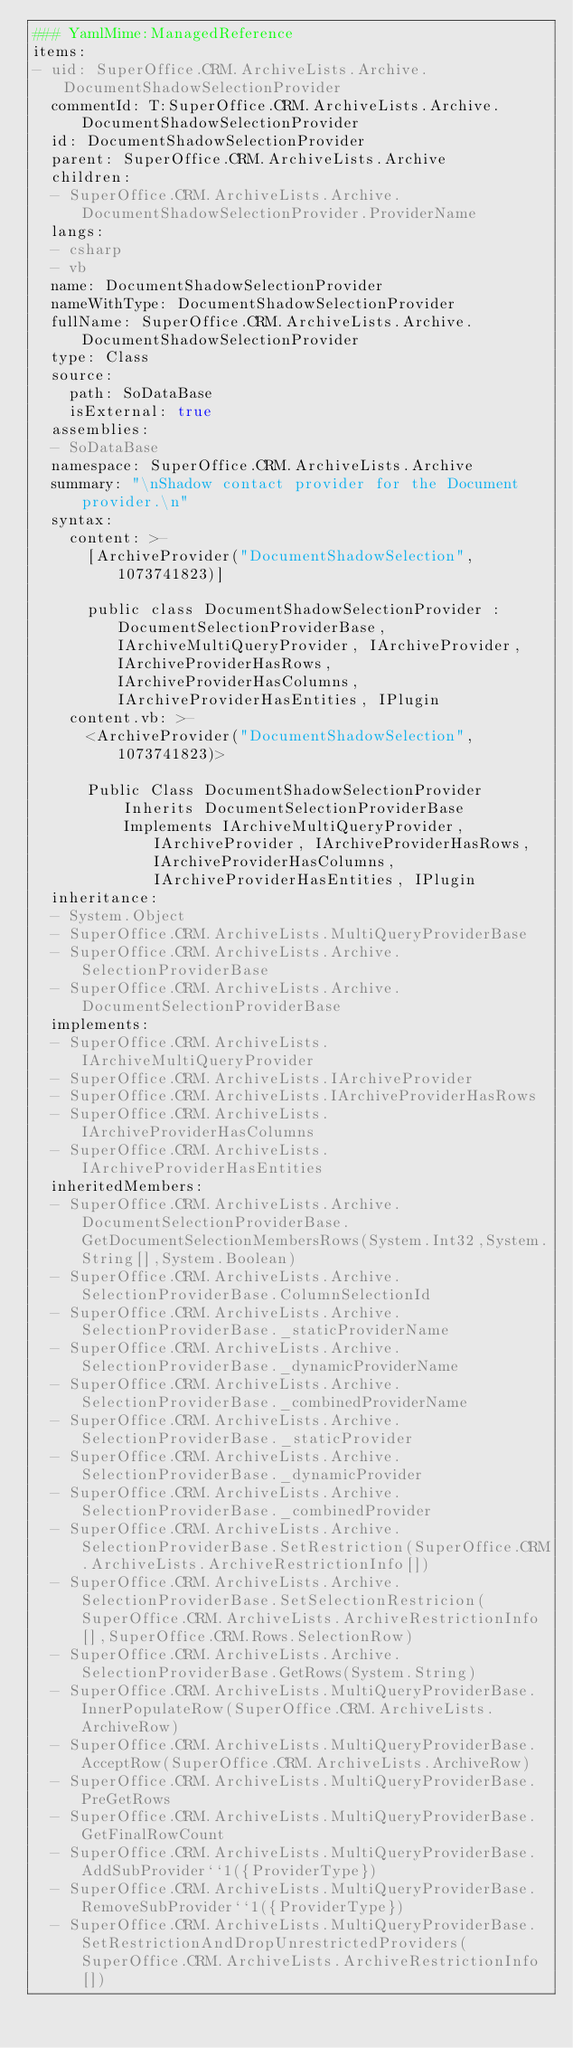<code> <loc_0><loc_0><loc_500><loc_500><_YAML_>### YamlMime:ManagedReference
items:
- uid: SuperOffice.CRM.ArchiveLists.Archive.DocumentShadowSelectionProvider
  commentId: T:SuperOffice.CRM.ArchiveLists.Archive.DocumentShadowSelectionProvider
  id: DocumentShadowSelectionProvider
  parent: SuperOffice.CRM.ArchiveLists.Archive
  children:
  - SuperOffice.CRM.ArchiveLists.Archive.DocumentShadowSelectionProvider.ProviderName
  langs:
  - csharp
  - vb
  name: DocumentShadowSelectionProvider
  nameWithType: DocumentShadowSelectionProvider
  fullName: SuperOffice.CRM.ArchiveLists.Archive.DocumentShadowSelectionProvider
  type: Class
  source:
    path: SoDataBase
    isExternal: true
  assemblies:
  - SoDataBase
  namespace: SuperOffice.CRM.ArchiveLists.Archive
  summary: "\nShadow contact provider for the Document provider.\n"
  syntax:
    content: >-
      [ArchiveProvider("DocumentShadowSelection", 1073741823)]

      public class DocumentShadowSelectionProvider : DocumentSelectionProviderBase, IArchiveMultiQueryProvider, IArchiveProvider, IArchiveProviderHasRows, IArchiveProviderHasColumns, IArchiveProviderHasEntities, IPlugin
    content.vb: >-
      <ArchiveProvider("DocumentShadowSelection", 1073741823)>

      Public Class DocumentShadowSelectionProvider
          Inherits DocumentSelectionProviderBase
          Implements IArchiveMultiQueryProvider, IArchiveProvider, IArchiveProviderHasRows, IArchiveProviderHasColumns, IArchiveProviderHasEntities, IPlugin
  inheritance:
  - System.Object
  - SuperOffice.CRM.ArchiveLists.MultiQueryProviderBase
  - SuperOffice.CRM.ArchiveLists.Archive.SelectionProviderBase
  - SuperOffice.CRM.ArchiveLists.Archive.DocumentSelectionProviderBase
  implements:
  - SuperOffice.CRM.ArchiveLists.IArchiveMultiQueryProvider
  - SuperOffice.CRM.ArchiveLists.IArchiveProvider
  - SuperOffice.CRM.ArchiveLists.IArchiveProviderHasRows
  - SuperOffice.CRM.ArchiveLists.IArchiveProviderHasColumns
  - SuperOffice.CRM.ArchiveLists.IArchiveProviderHasEntities
  inheritedMembers:
  - SuperOffice.CRM.ArchiveLists.Archive.DocumentSelectionProviderBase.GetDocumentSelectionMembersRows(System.Int32,System.String[],System.Boolean)
  - SuperOffice.CRM.ArchiveLists.Archive.SelectionProviderBase.ColumnSelectionId
  - SuperOffice.CRM.ArchiveLists.Archive.SelectionProviderBase._staticProviderName
  - SuperOffice.CRM.ArchiveLists.Archive.SelectionProviderBase._dynamicProviderName
  - SuperOffice.CRM.ArchiveLists.Archive.SelectionProviderBase._combinedProviderName
  - SuperOffice.CRM.ArchiveLists.Archive.SelectionProviderBase._staticProvider
  - SuperOffice.CRM.ArchiveLists.Archive.SelectionProviderBase._dynamicProvider
  - SuperOffice.CRM.ArchiveLists.Archive.SelectionProviderBase._combinedProvider
  - SuperOffice.CRM.ArchiveLists.Archive.SelectionProviderBase.SetRestriction(SuperOffice.CRM.ArchiveLists.ArchiveRestrictionInfo[])
  - SuperOffice.CRM.ArchiveLists.Archive.SelectionProviderBase.SetSelectionRestricion(SuperOffice.CRM.ArchiveLists.ArchiveRestrictionInfo[],SuperOffice.CRM.Rows.SelectionRow)
  - SuperOffice.CRM.ArchiveLists.Archive.SelectionProviderBase.GetRows(System.String)
  - SuperOffice.CRM.ArchiveLists.MultiQueryProviderBase.InnerPopulateRow(SuperOffice.CRM.ArchiveLists.ArchiveRow)
  - SuperOffice.CRM.ArchiveLists.MultiQueryProviderBase.AcceptRow(SuperOffice.CRM.ArchiveLists.ArchiveRow)
  - SuperOffice.CRM.ArchiveLists.MultiQueryProviderBase.PreGetRows
  - SuperOffice.CRM.ArchiveLists.MultiQueryProviderBase.GetFinalRowCount
  - SuperOffice.CRM.ArchiveLists.MultiQueryProviderBase.AddSubProvider``1({ProviderType})
  - SuperOffice.CRM.ArchiveLists.MultiQueryProviderBase.RemoveSubProvider``1({ProviderType})
  - SuperOffice.CRM.ArchiveLists.MultiQueryProviderBase.SetRestrictionAndDropUnrestrictedProviders(SuperOffice.CRM.ArchiveLists.ArchiveRestrictionInfo[])</code> 